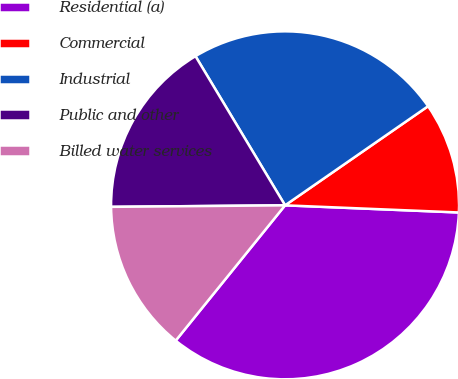<chart> <loc_0><loc_0><loc_500><loc_500><pie_chart><fcel>Residential (a)<fcel>Commercial<fcel>Industrial<fcel>Public and other<fcel>Billed water services<nl><fcel>35.16%<fcel>10.3%<fcel>23.96%<fcel>16.53%<fcel>14.04%<nl></chart> 